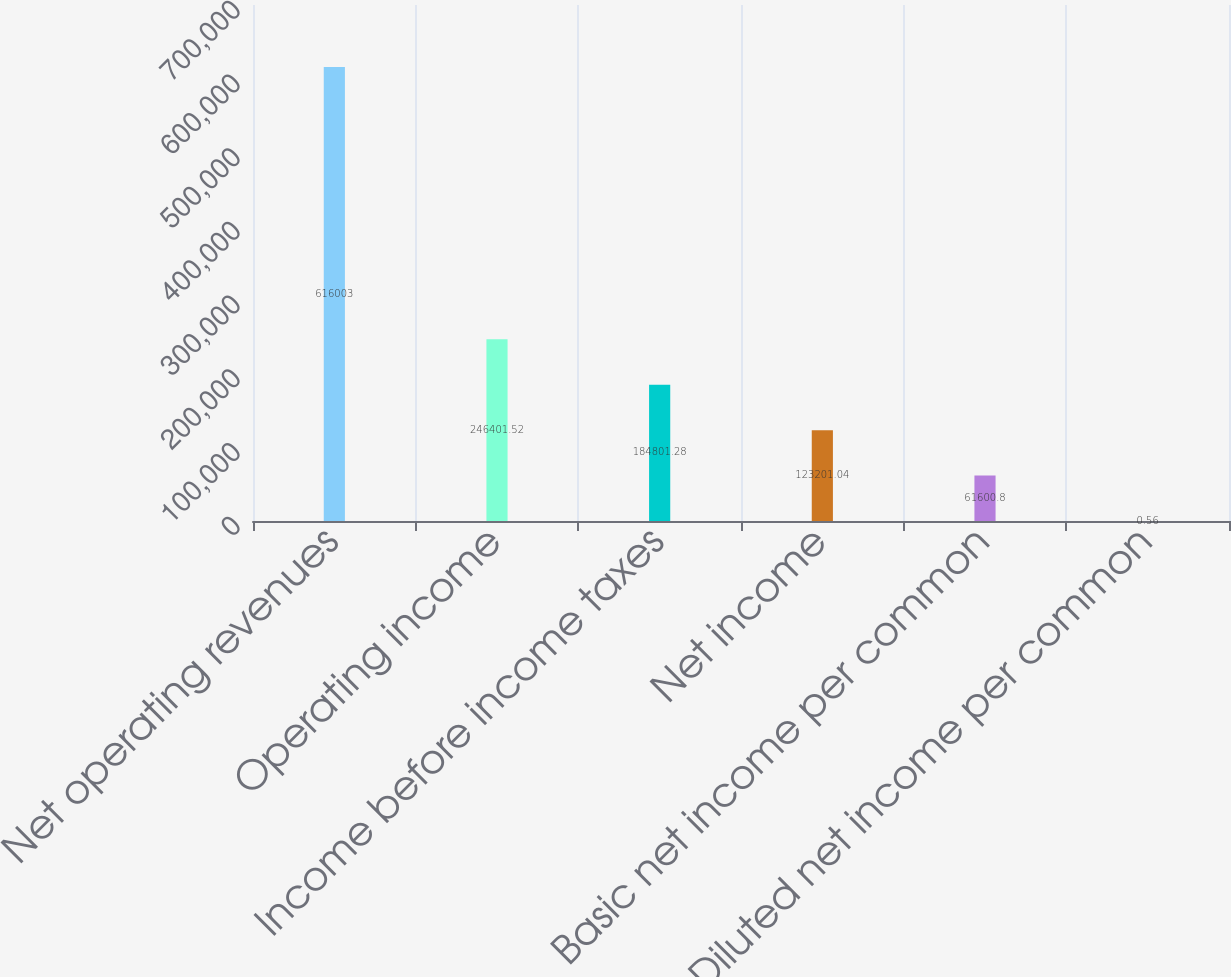Convert chart. <chart><loc_0><loc_0><loc_500><loc_500><bar_chart><fcel>Net operating revenues<fcel>Operating income<fcel>Income before income taxes<fcel>Net income<fcel>Basic net income per common<fcel>Diluted net income per common<nl><fcel>616003<fcel>246402<fcel>184801<fcel>123201<fcel>61600.8<fcel>0.56<nl></chart> 